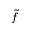<formula> <loc_0><loc_0><loc_500><loc_500>\tilde { f }</formula> 